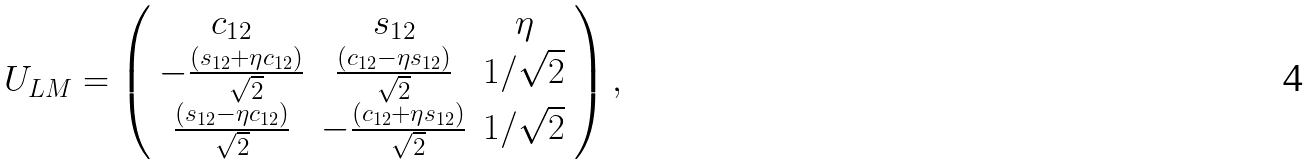Convert formula to latex. <formula><loc_0><loc_0><loc_500><loc_500>U _ { L M } = \left ( \begin{array} { c c c } c _ { 1 2 } & s _ { 1 2 } & \eta \\ - \frac { ( s _ { 1 2 } + \eta c _ { 1 2 } ) } { \sqrt { 2 } } & \frac { ( c _ { 1 2 } - \eta s _ { 1 2 } ) } { \sqrt { 2 } } & 1 / \sqrt { 2 } \\ \frac { ( s _ { 1 2 } - \eta c _ { 1 2 } ) } { \sqrt { 2 } } & - \frac { ( c _ { 1 2 } + \eta s _ { 1 2 } ) } { \sqrt { 2 } } & 1 / \sqrt { 2 } \end{array} \right ) ,</formula> 